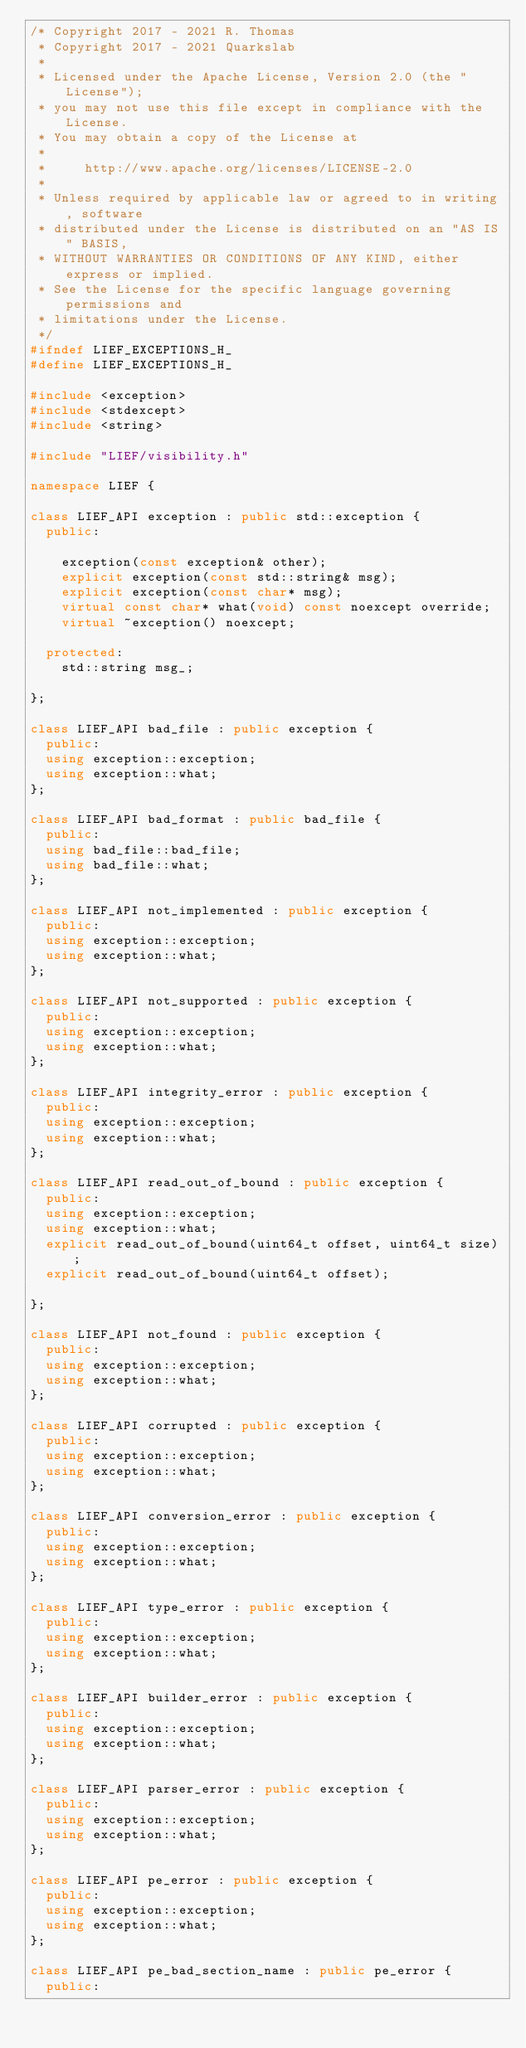<code> <loc_0><loc_0><loc_500><loc_500><_C++_>/* Copyright 2017 - 2021 R. Thomas
 * Copyright 2017 - 2021 Quarkslab
 *
 * Licensed under the Apache License, Version 2.0 (the "License");
 * you may not use this file except in compliance with the License.
 * You may obtain a copy of the License at
 *
 *     http://www.apache.org/licenses/LICENSE-2.0
 *
 * Unless required by applicable law or agreed to in writing, software
 * distributed under the License is distributed on an "AS IS" BASIS,
 * WITHOUT WARRANTIES OR CONDITIONS OF ANY KIND, either express or implied.
 * See the License for the specific language governing permissions and
 * limitations under the License.
 */
#ifndef LIEF_EXCEPTIONS_H_
#define LIEF_EXCEPTIONS_H_

#include <exception>
#include <stdexcept>
#include <string>

#include "LIEF/visibility.h"

namespace LIEF {

class LIEF_API exception : public std::exception {
  public:

    exception(const exception& other);
    explicit exception(const std::string& msg);
    explicit exception(const char* msg);
    virtual const char* what(void) const noexcept override;
    virtual ~exception() noexcept;

  protected:
    std::string msg_;

};

class LIEF_API bad_file : public exception {
  public:
  using exception::exception;
  using exception::what;
};

class LIEF_API bad_format : public bad_file {
  public:
  using bad_file::bad_file;
  using bad_file::what;
};

class LIEF_API not_implemented : public exception {
  public:
  using exception::exception;
  using exception::what;
};

class LIEF_API not_supported : public exception {
  public:
  using exception::exception;
  using exception::what;
};

class LIEF_API integrity_error : public exception {
  public:
  using exception::exception;
  using exception::what;
};

class LIEF_API read_out_of_bound : public exception {
  public:
  using exception::exception;
  using exception::what;
  explicit read_out_of_bound(uint64_t offset, uint64_t size);
  explicit read_out_of_bound(uint64_t offset);

};

class LIEF_API not_found : public exception {
  public:
  using exception::exception;
  using exception::what;
};

class LIEF_API corrupted : public exception {
  public:
  using exception::exception;
  using exception::what;
};

class LIEF_API conversion_error : public exception {
  public:
  using exception::exception;
  using exception::what;
};

class LIEF_API type_error : public exception {
  public:
  using exception::exception;
  using exception::what;
};

class LIEF_API builder_error : public exception {
  public:
  using exception::exception;
  using exception::what;
};

class LIEF_API parser_error : public exception {
  public:
  using exception::exception;
  using exception::what;
};

class LIEF_API pe_error : public exception {
  public:
  using exception::exception;
  using exception::what;
};

class LIEF_API pe_bad_section_name : public pe_error {
  public:</code> 